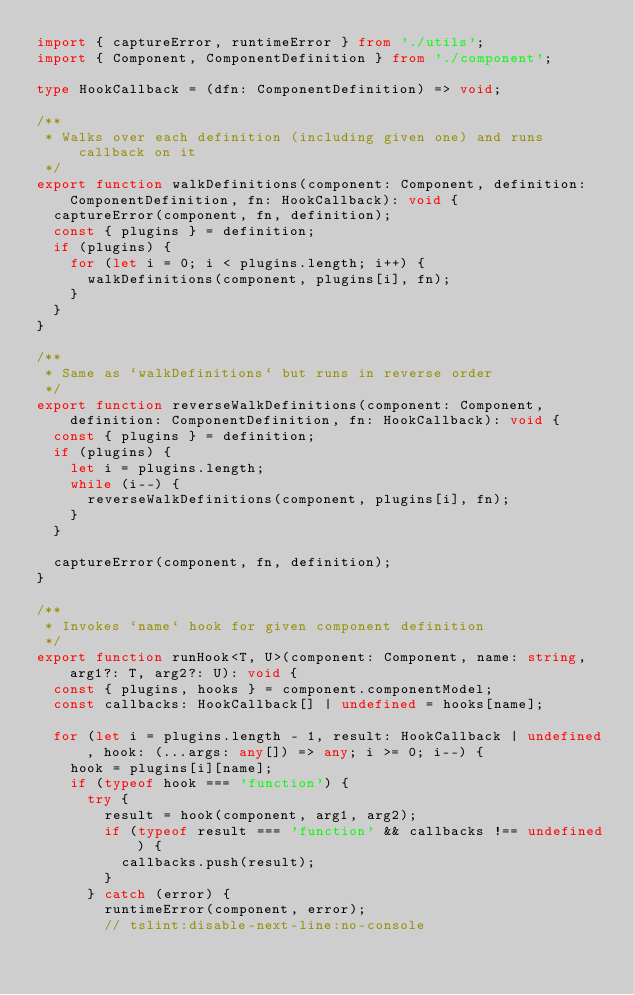Convert code to text. <code><loc_0><loc_0><loc_500><loc_500><_TypeScript_>import { captureError, runtimeError } from './utils';
import { Component, ComponentDefinition } from './component';

type HookCallback = (dfn: ComponentDefinition) => void;

/**
 * Walks over each definition (including given one) and runs callback on it
 */
export function walkDefinitions(component: Component, definition: ComponentDefinition, fn: HookCallback): void {
	captureError(component, fn, definition);
	const { plugins } = definition;
	if (plugins) {
		for (let i = 0; i < plugins.length; i++) {
			walkDefinitions(component, plugins[i], fn);
		}
	}
}

/**
 * Same as `walkDefinitions` but runs in reverse order
 */
export function reverseWalkDefinitions(component: Component, definition: ComponentDefinition, fn: HookCallback): void {
	const { plugins } = definition;
	if (plugins) {
		let i = plugins.length;
		while (i--) {
			reverseWalkDefinitions(component, plugins[i], fn);
		}
	}

	captureError(component, fn, definition);
}

/**
 * Invokes `name` hook for given component definition
 */
export function runHook<T, U>(component: Component, name: string, arg1?: T, arg2?: U): void {
	const { plugins, hooks } = component.componentModel;
	const callbacks: HookCallback[] | undefined = hooks[name];

	for (let i = plugins.length - 1, result: HookCallback | undefined, hook: (...args: any[]) => any; i >= 0; i--) {
		hook = plugins[i][name];
		if (typeof hook === 'function') {
			try {
				result = hook(component, arg1, arg2);
				if (typeof result === 'function' && callbacks !== undefined) {
					callbacks.push(result);
				}
			} catch (error) {
				runtimeError(component, error);
				// tslint:disable-next-line:no-console</code> 